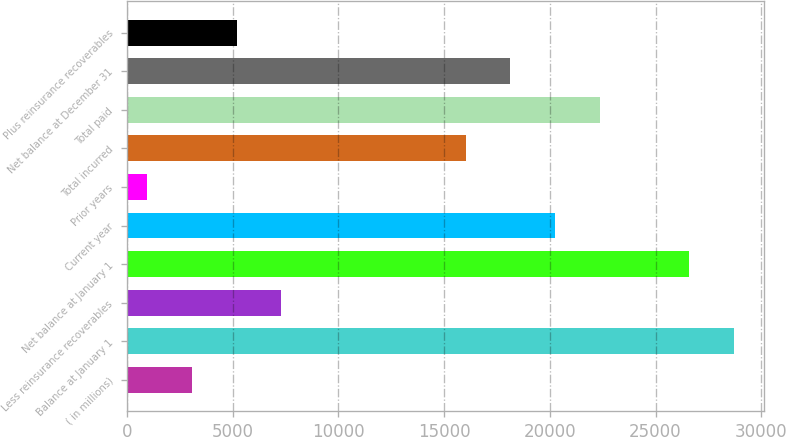Convert chart. <chart><loc_0><loc_0><loc_500><loc_500><bar_chart><fcel>( in millions)<fcel>Balance at January 1<fcel>Less reinsurance recoverables<fcel>Net balance at January 1<fcel>Current year<fcel>Prior years<fcel>Total incurred<fcel>Total paid<fcel>Net balance at December 31<fcel>Plus reinsurance recoverables<nl><fcel>3085.6<fcel>28704.6<fcel>7314.8<fcel>26590<fcel>20246.2<fcel>971<fcel>16017<fcel>22360.8<fcel>18131.6<fcel>5200.2<nl></chart> 